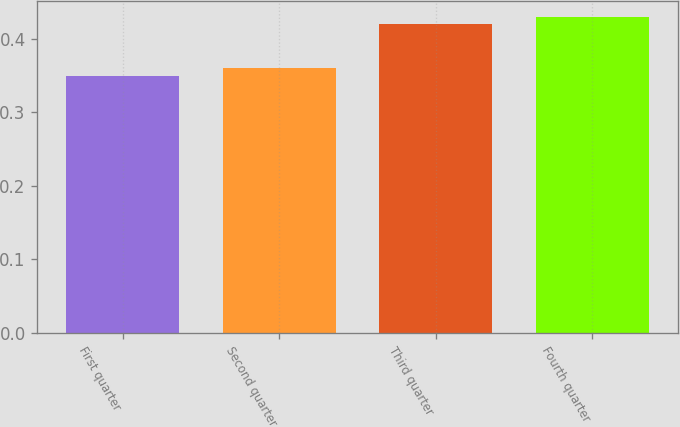<chart> <loc_0><loc_0><loc_500><loc_500><bar_chart><fcel>First quarter<fcel>Second quarter<fcel>Third quarter<fcel>Fourth quarter<nl><fcel>0.35<fcel>0.36<fcel>0.42<fcel>0.43<nl></chart> 